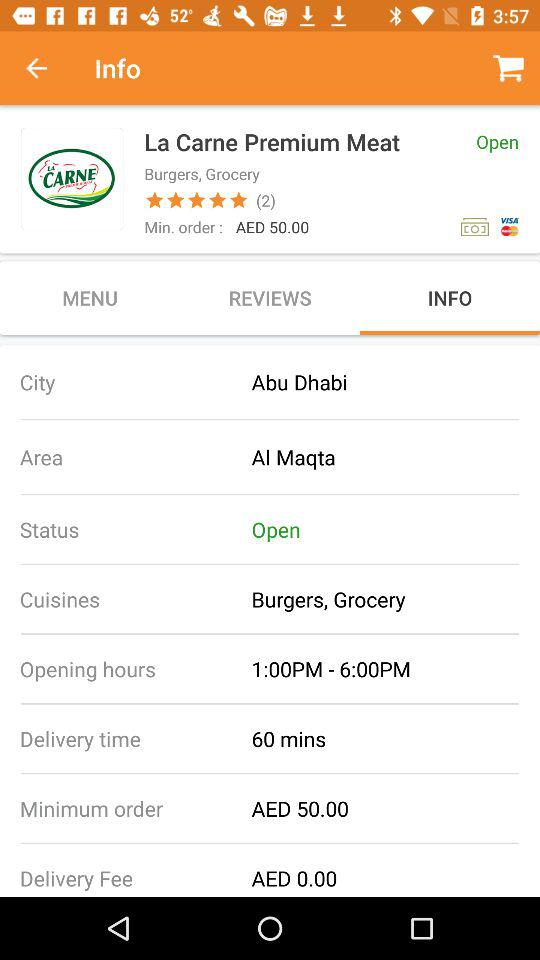What is the name of the city? The name of the city is Abu Dhabi. 